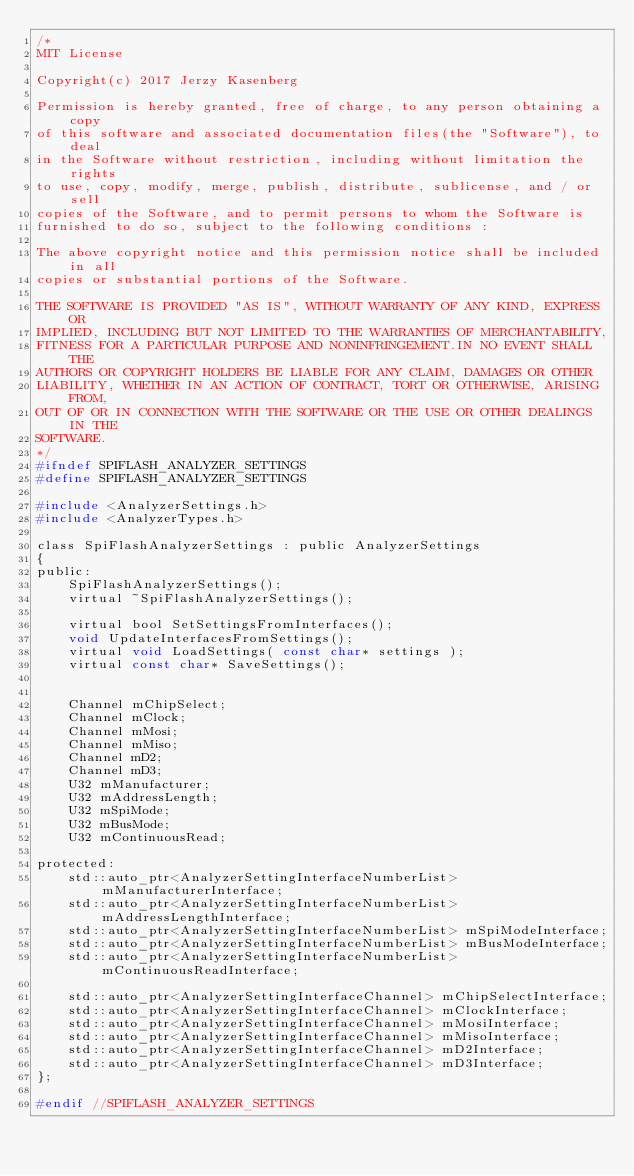Convert code to text. <code><loc_0><loc_0><loc_500><loc_500><_C_>/*
MIT License

Copyright(c) 2017 Jerzy Kasenberg

Permission is hereby granted, free of charge, to any person obtaining a copy
of this software and associated documentation files(the "Software"), to deal
in the Software without restriction, including without limitation the rights
to use, copy, modify, merge, publish, distribute, sublicense, and / or sell
copies of the Software, and to permit persons to whom the Software is
furnished to do so, subject to the following conditions :

The above copyright notice and this permission notice shall be included in all
copies or substantial portions of the Software.

THE SOFTWARE IS PROVIDED "AS IS", WITHOUT WARRANTY OF ANY KIND, EXPRESS OR
IMPLIED, INCLUDING BUT NOT LIMITED TO THE WARRANTIES OF MERCHANTABILITY,
FITNESS FOR A PARTICULAR PURPOSE AND NONINFRINGEMENT.IN NO EVENT SHALL THE
AUTHORS OR COPYRIGHT HOLDERS BE LIABLE FOR ANY CLAIM, DAMAGES OR OTHER
LIABILITY, WHETHER IN AN ACTION OF CONTRACT, TORT OR OTHERWISE, ARISING FROM,
OUT OF OR IN CONNECTION WITH THE SOFTWARE OR THE USE OR OTHER DEALINGS IN THE
SOFTWARE.
*/
#ifndef SPIFLASH_ANALYZER_SETTINGS
#define SPIFLASH_ANALYZER_SETTINGS

#include <AnalyzerSettings.h>
#include <AnalyzerTypes.h>

class SpiFlashAnalyzerSettings : public AnalyzerSettings
{
public:
	SpiFlashAnalyzerSettings();
	virtual ~SpiFlashAnalyzerSettings();

	virtual bool SetSettingsFromInterfaces();
	void UpdateInterfacesFromSettings();
	virtual void LoadSettings( const char* settings );
	virtual const char* SaveSettings();


	Channel mChipSelect;
	Channel mClock;
	Channel mMosi;
	Channel mMiso;
	Channel mD2;
	Channel mD3;
	U32 mManufacturer;
	U32 mAddressLength;
	U32 mSpiMode;
	U32 mBusMode;
	U32 mContinuousRead;

protected:
	std::auto_ptr<AnalyzerSettingInterfaceNumberList> mManufacturerInterface;
	std::auto_ptr<AnalyzerSettingInterfaceNumberList> mAddressLengthInterface;
	std::auto_ptr<AnalyzerSettingInterfaceNumberList> mSpiModeInterface;
	std::auto_ptr<AnalyzerSettingInterfaceNumberList> mBusModeInterface;
	std::auto_ptr<AnalyzerSettingInterfaceNumberList> mContinuousReadInterface;

	std::auto_ptr<AnalyzerSettingInterfaceChannel> mChipSelectInterface;
	std::auto_ptr<AnalyzerSettingInterfaceChannel> mClockInterface;
	std::auto_ptr<AnalyzerSettingInterfaceChannel> mMosiInterface;
	std::auto_ptr<AnalyzerSettingInterfaceChannel> mMisoInterface;
	std::auto_ptr<AnalyzerSettingInterfaceChannel> mD2Interface;
	std::auto_ptr<AnalyzerSettingInterfaceChannel> mD3Interface;
};

#endif //SPIFLASH_ANALYZER_SETTINGS
</code> 